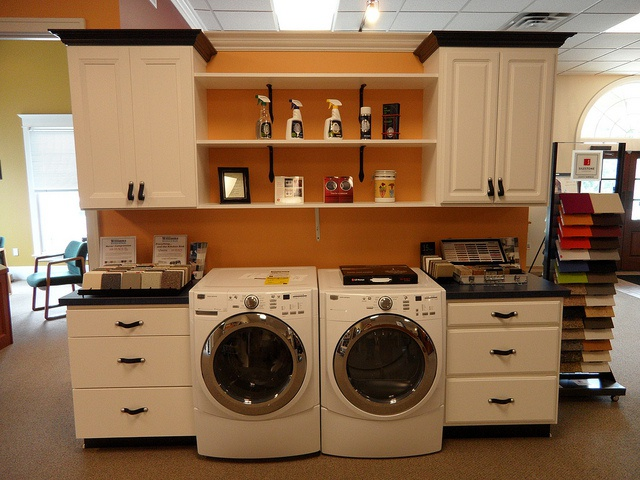Describe the objects in this image and their specific colors. I can see chair in maroon, white, black, teal, and gray tones, book in maroon and black tones, book in maroon, gray, tan, and black tones, book in maroon, black, and brown tones, and bottle in maroon, tan, black, and gray tones in this image. 